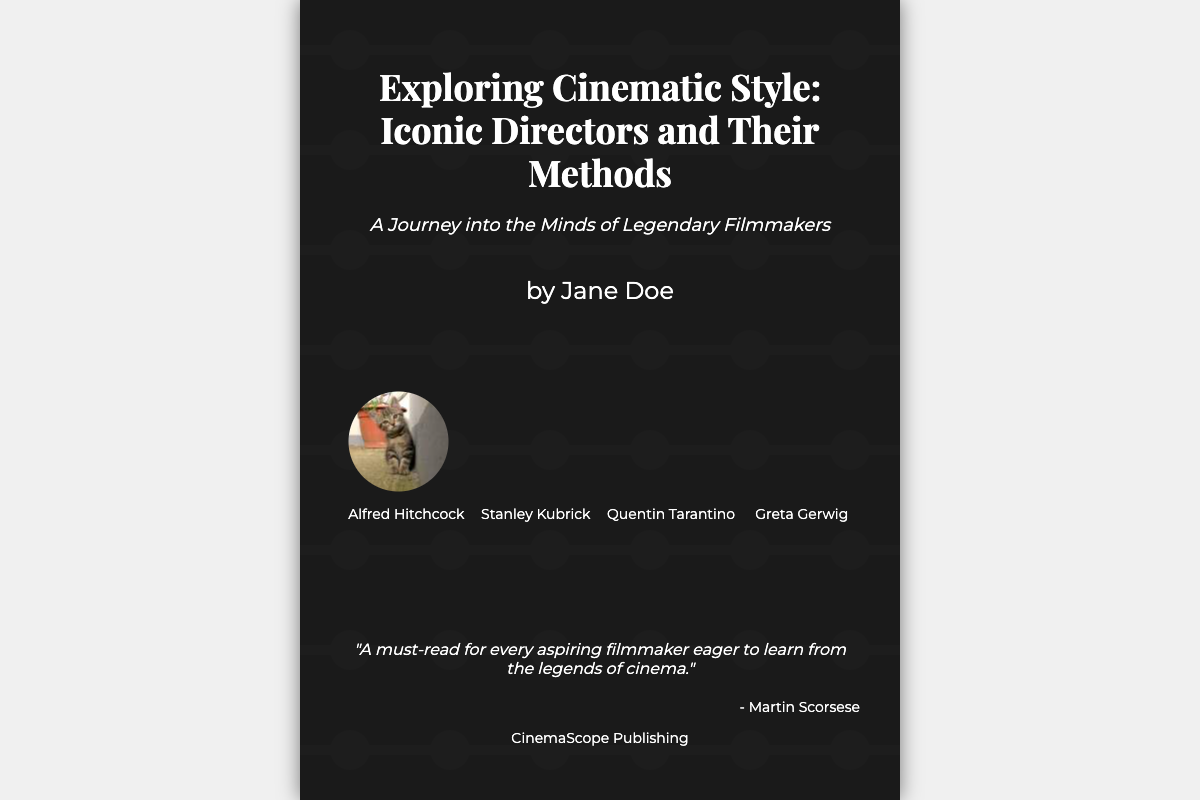what is the title of the book? The title of the book is displayed prominently at the top of the cover design.
Answer: Exploring Cinematic Style: Iconic Directors and Their Methods who is the author of the book? The author's name is mentioned below the book title in a clear font.
Answer: Jane Doe how many directors are featured on the book cover? The cover features a section that includes images and names of several directors.
Answer: Four which publisher is associated with the book? The publisher's name is found at the bottom of the cover design.
Answer: CinemaScope Publishing what is the subtitle of the book? The subtitle provides additional context about the book's content underneath the title.
Answer: A Journey into the Minds of Legendary Filmmakers who is quoted on the book cover? The quotation on the cover is attributed to a well-known filmmaker, adding credibility.
Answer: Martin Scorsese what is the main theme of the book? The theme can be inferred from the title and subtitle, highlighting its focus.
Answer: Filmmaking styles which director's name is listed first on the cover? The sequence of directors is shown, listing their names in a specific order.
Answer: Alfred Hitchcock what is the genre of this document? The type of this document can be categorized based on its content and purpose.
Answer: Non-fiction 